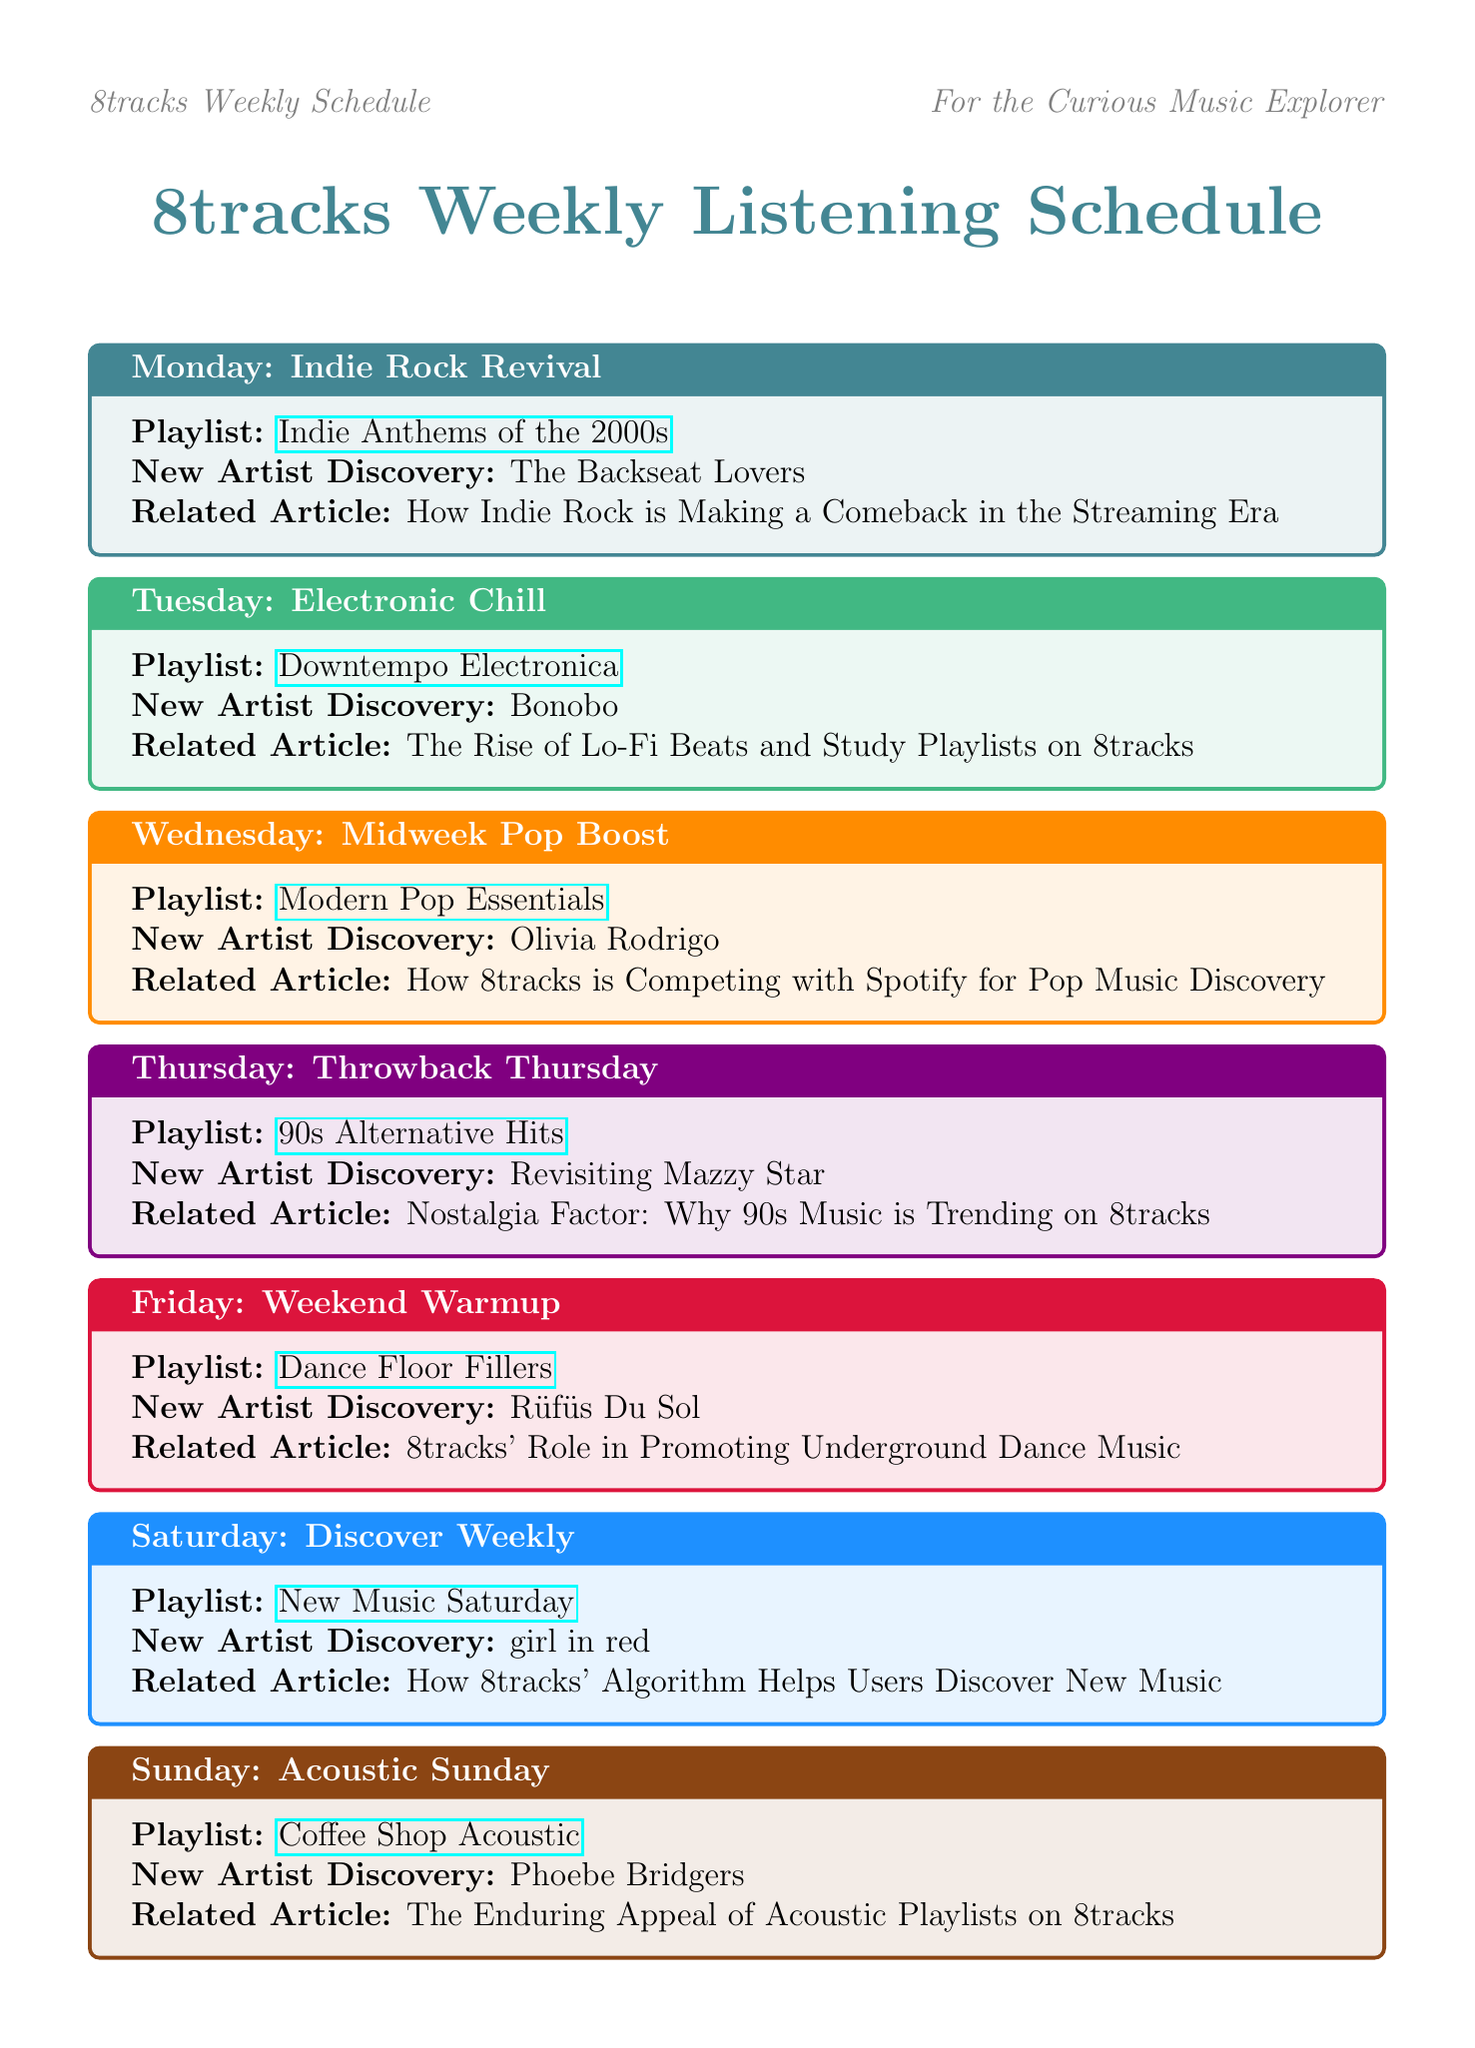What is the playlist for Monday? The playlist for Monday is listed under the theme "Indie Rock Revival," which is "Indie Anthems of the 2000s."
Answer: Indie Anthems of the 2000s Who is the new artist discovery for Friday? The new artist discovery for Friday is specified in the schedule, which is "Rüfüs Du Sol."
Answer: Rüfüs Du Sol What is the theme for Wednesday? The theme for Wednesday is described as "Midweek Pop Boost."
Answer: Midweek Pop Boost Which article is related to Saturday’s playlist? The article related to Saturday's playlist discusses how 8tracks' algorithm helps users discover new music.
Answer: How 8tracks' Algorithm Helps Users Discover New Music What playlist is featured on Sunday? The schedule includes a specific playlist for Sunday, which is "Coffee Shop Acoustic."
Answer: Coffee Shop Acoustic How many playlists are listed in the weekly schedule? The document contains a total of seven playlists listed for each day of the week.
Answer: Seven What type of content is featured on the following Thursday? The type of content presented for Thursday is specified as "Throwback Thursday."
Answer: Throwback Thursday What podcast is highlighted in the featured content? The highlighted podcast in the featured content is titled "8tracks Insider: The Future of Playlist Curation."
Answer: 8tracks Insider: The Future of Playlist Curation What overarching topic unites the industry insights? The overarching themes discussed in the industry insights pertain to the challenges and evolution within the music streaming landscape.
Answer: The Impact of AI on Music Curation 